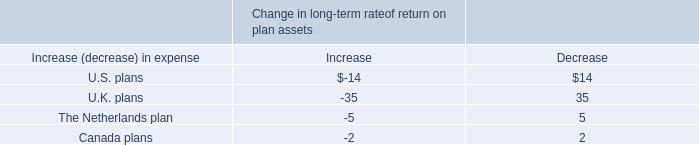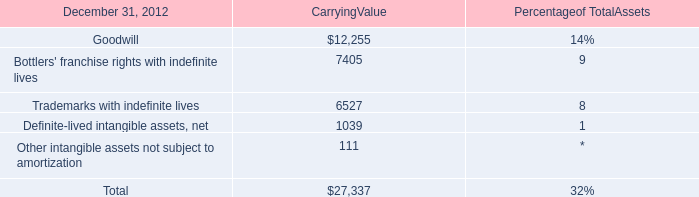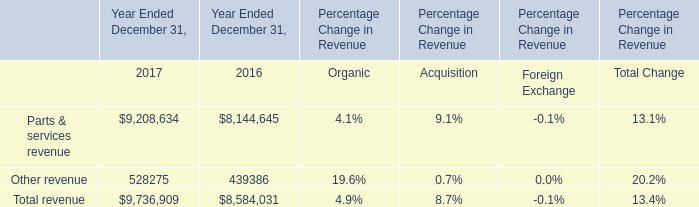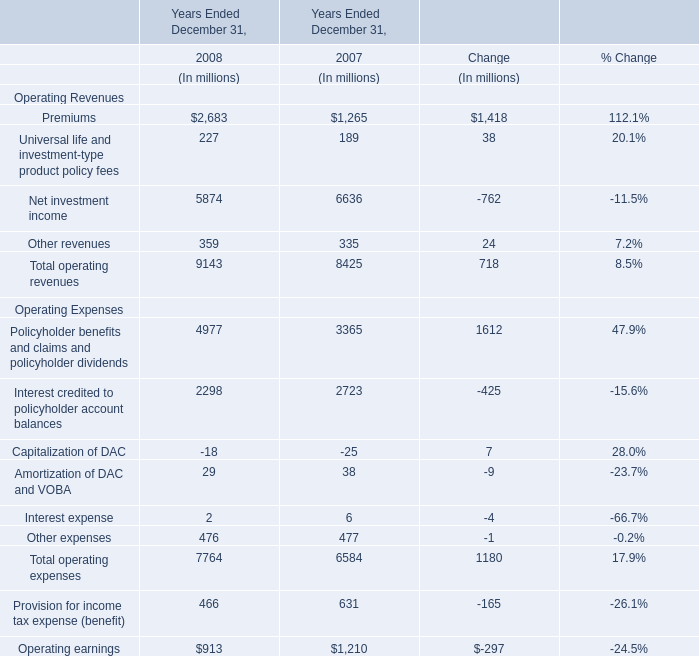What's the sum of all Operating Revenues that is positive in 2008? (in million) 
Computations: (((2683 + 227) + 5874) + 359)
Answer: 9143.0. 